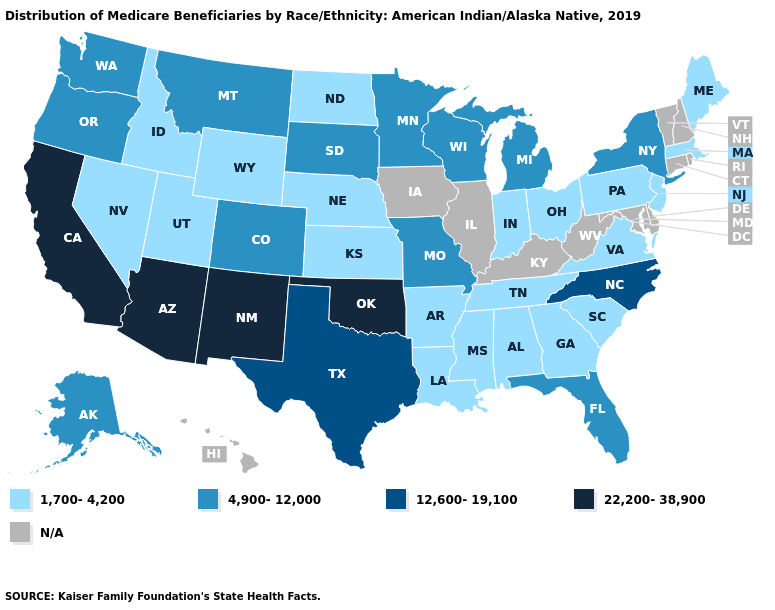What is the highest value in the USA?
Answer briefly. 22,200-38,900. Is the legend a continuous bar?
Give a very brief answer. No. Name the states that have a value in the range 4,900-12,000?
Answer briefly. Alaska, Colorado, Florida, Michigan, Minnesota, Missouri, Montana, New York, Oregon, South Dakota, Washington, Wisconsin. Among the states that border Nevada , does Idaho have the highest value?
Concise answer only. No. Among the states that border Utah , which have the lowest value?
Be succinct. Idaho, Nevada, Wyoming. Name the states that have a value in the range 22,200-38,900?
Give a very brief answer. Arizona, California, New Mexico, Oklahoma. Among the states that border Indiana , does Ohio have the lowest value?
Answer briefly. Yes. What is the highest value in states that border Oklahoma?
Keep it brief. 22,200-38,900. What is the value of Rhode Island?
Quick response, please. N/A. Name the states that have a value in the range N/A?
Give a very brief answer. Connecticut, Delaware, Hawaii, Illinois, Iowa, Kentucky, Maryland, New Hampshire, Rhode Island, Vermont, West Virginia. Among the states that border Indiana , does Ohio have the highest value?
Answer briefly. No. Does the first symbol in the legend represent the smallest category?
Concise answer only. Yes. Does Oklahoma have the highest value in the USA?
Give a very brief answer. Yes. 